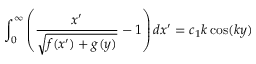Convert formula to latex. <formula><loc_0><loc_0><loc_500><loc_500>\int _ { 0 } ^ { \infty } \left ( \frac { x ^ { \prime } } { \sqrt { f ( x ^ { \prime } ) + g ( y ) } } - 1 \right ) d x ^ { \prime } = c _ { 1 } k \cos ( k y )</formula> 